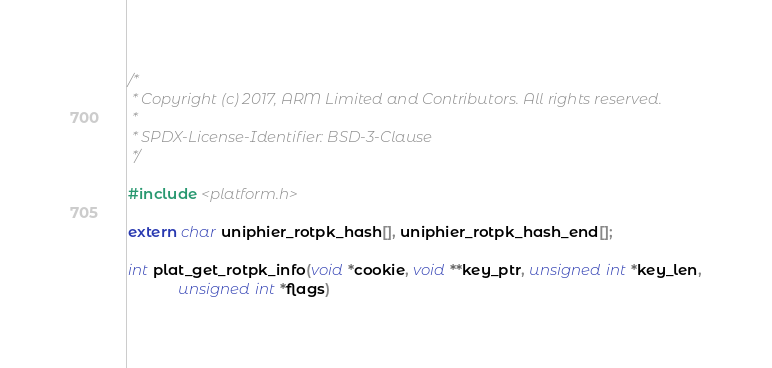Convert code to text. <code><loc_0><loc_0><loc_500><loc_500><_C_>/*
 * Copyright (c) 2017, ARM Limited and Contributors. All rights reserved.
 *
 * SPDX-License-Identifier: BSD-3-Clause
 */

#include <platform.h>

extern char uniphier_rotpk_hash[], uniphier_rotpk_hash_end[];

int plat_get_rotpk_info(void *cookie, void **key_ptr, unsigned int *key_len,
			unsigned int *flags)</code> 